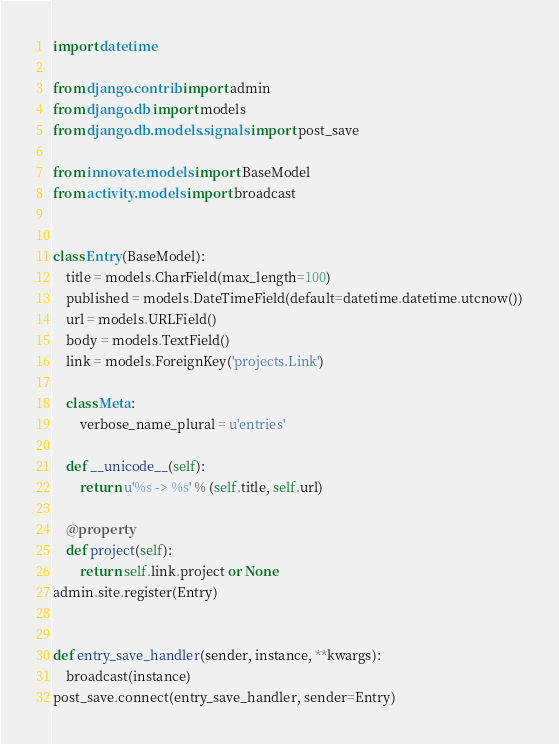Convert code to text. <code><loc_0><loc_0><loc_500><loc_500><_Python_>import datetime

from django.contrib import admin
from django.db import models
from django.db.models.signals import post_save

from innovate.models import BaseModel
from activity.models import broadcast


class Entry(BaseModel):
    title = models.CharField(max_length=100)
    published = models.DateTimeField(default=datetime.datetime.utcnow())
    url = models.URLField()
    body = models.TextField()
    link = models.ForeignKey('projects.Link')

    class Meta:
        verbose_name_plural = u'entries'

    def __unicode__(self):
        return u'%s -> %s' % (self.title, self.url)

    @property
    def project(self):
        return self.link.project or None
admin.site.register(Entry)


def entry_save_handler(sender, instance, **kwargs):
    broadcast(instance)
post_save.connect(entry_save_handler, sender=Entry)
</code> 